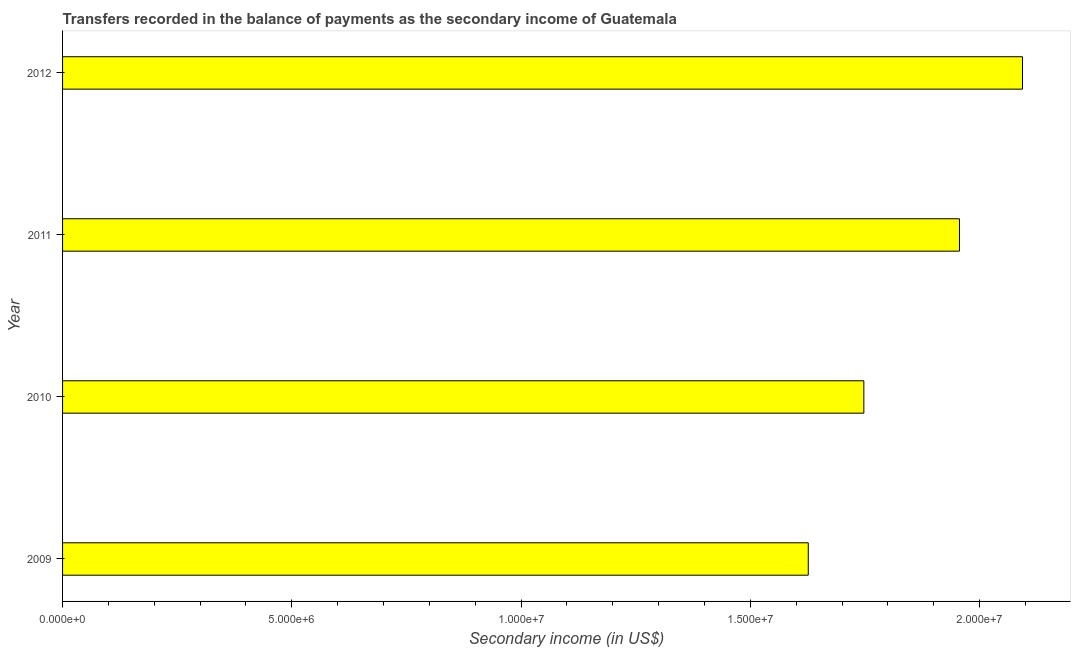What is the title of the graph?
Offer a very short reply. Transfers recorded in the balance of payments as the secondary income of Guatemala. What is the label or title of the X-axis?
Offer a very short reply. Secondary income (in US$). What is the amount of secondary income in 2011?
Your answer should be very brief. 1.96e+07. Across all years, what is the maximum amount of secondary income?
Provide a succinct answer. 2.09e+07. Across all years, what is the minimum amount of secondary income?
Give a very brief answer. 1.63e+07. In which year was the amount of secondary income minimum?
Make the answer very short. 2009. What is the sum of the amount of secondary income?
Make the answer very short. 7.42e+07. What is the difference between the amount of secondary income in 2011 and 2012?
Offer a very short reply. -1.37e+06. What is the average amount of secondary income per year?
Offer a terse response. 1.86e+07. What is the median amount of secondary income?
Keep it short and to the point. 1.85e+07. Do a majority of the years between 2009 and 2012 (inclusive) have amount of secondary income greater than 10000000 US$?
Make the answer very short. Yes. What is the ratio of the amount of secondary income in 2010 to that in 2012?
Ensure brevity in your answer.  0.83. Is the amount of secondary income in 2010 less than that in 2012?
Your answer should be compact. Yes. Is the difference between the amount of secondary income in 2009 and 2011 greater than the difference between any two years?
Keep it short and to the point. No. What is the difference between the highest and the second highest amount of secondary income?
Provide a succinct answer. 1.37e+06. Is the sum of the amount of secondary income in 2011 and 2012 greater than the maximum amount of secondary income across all years?
Keep it short and to the point. Yes. What is the difference between the highest and the lowest amount of secondary income?
Your answer should be very brief. 4.67e+06. In how many years, is the amount of secondary income greater than the average amount of secondary income taken over all years?
Provide a succinct answer. 2. What is the difference between two consecutive major ticks on the X-axis?
Offer a very short reply. 5.00e+06. Are the values on the major ticks of X-axis written in scientific E-notation?
Provide a short and direct response. Yes. What is the Secondary income (in US$) in 2009?
Give a very brief answer. 1.63e+07. What is the Secondary income (in US$) in 2010?
Provide a short and direct response. 1.75e+07. What is the Secondary income (in US$) in 2011?
Provide a succinct answer. 1.96e+07. What is the Secondary income (in US$) in 2012?
Ensure brevity in your answer.  2.09e+07. What is the difference between the Secondary income (in US$) in 2009 and 2010?
Provide a succinct answer. -1.21e+06. What is the difference between the Secondary income (in US$) in 2009 and 2011?
Make the answer very short. -3.30e+06. What is the difference between the Secondary income (in US$) in 2009 and 2012?
Offer a very short reply. -4.67e+06. What is the difference between the Secondary income (in US$) in 2010 and 2011?
Give a very brief answer. -2.09e+06. What is the difference between the Secondary income (in US$) in 2010 and 2012?
Offer a terse response. -3.46e+06. What is the difference between the Secondary income (in US$) in 2011 and 2012?
Offer a terse response. -1.37e+06. What is the ratio of the Secondary income (in US$) in 2009 to that in 2011?
Ensure brevity in your answer.  0.83. What is the ratio of the Secondary income (in US$) in 2009 to that in 2012?
Offer a terse response. 0.78. What is the ratio of the Secondary income (in US$) in 2010 to that in 2011?
Your answer should be compact. 0.89. What is the ratio of the Secondary income (in US$) in 2010 to that in 2012?
Your answer should be compact. 0.83. What is the ratio of the Secondary income (in US$) in 2011 to that in 2012?
Your answer should be very brief. 0.93. 